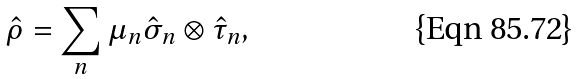<formula> <loc_0><loc_0><loc_500><loc_500>\hat { \rho } = \sum _ { n } \mu _ { n } \hat { \sigma } _ { n } \otimes \hat { \tau } _ { n } ,</formula> 